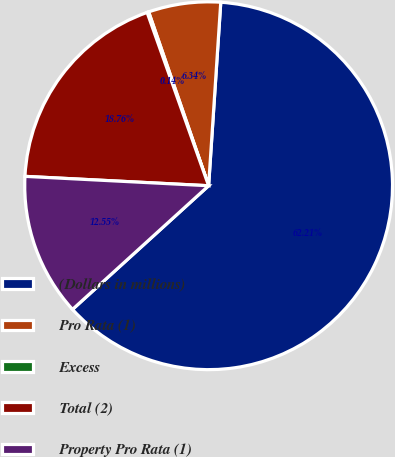Convert chart. <chart><loc_0><loc_0><loc_500><loc_500><pie_chart><fcel>(Dollars in millions)<fcel>Pro Rata (1)<fcel>Excess<fcel>Total (2)<fcel>Property Pro Rata (1)<nl><fcel>62.21%<fcel>6.34%<fcel>0.14%<fcel>18.76%<fcel>12.55%<nl></chart> 